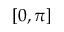<formula> <loc_0><loc_0><loc_500><loc_500>[ 0 , \pi ]</formula> 